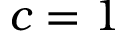Convert formula to latex. <formula><loc_0><loc_0><loc_500><loc_500>c = 1</formula> 